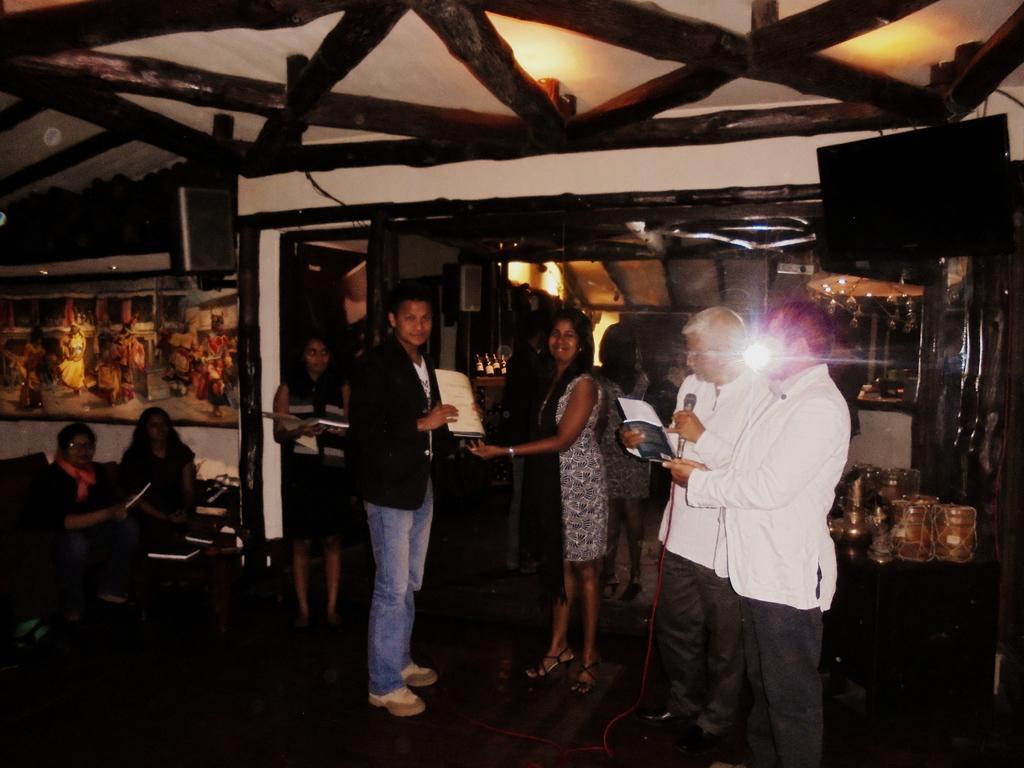Could you give a brief overview of what you see in this image? I can see a group of people standing and two people are sitting. This is the frame attached to the wall. This looks like a wooden roof. I can see two men holding a mike and a book. This looks like a table with few objects on it. I can see the TV screen, which is attached to the wall. 